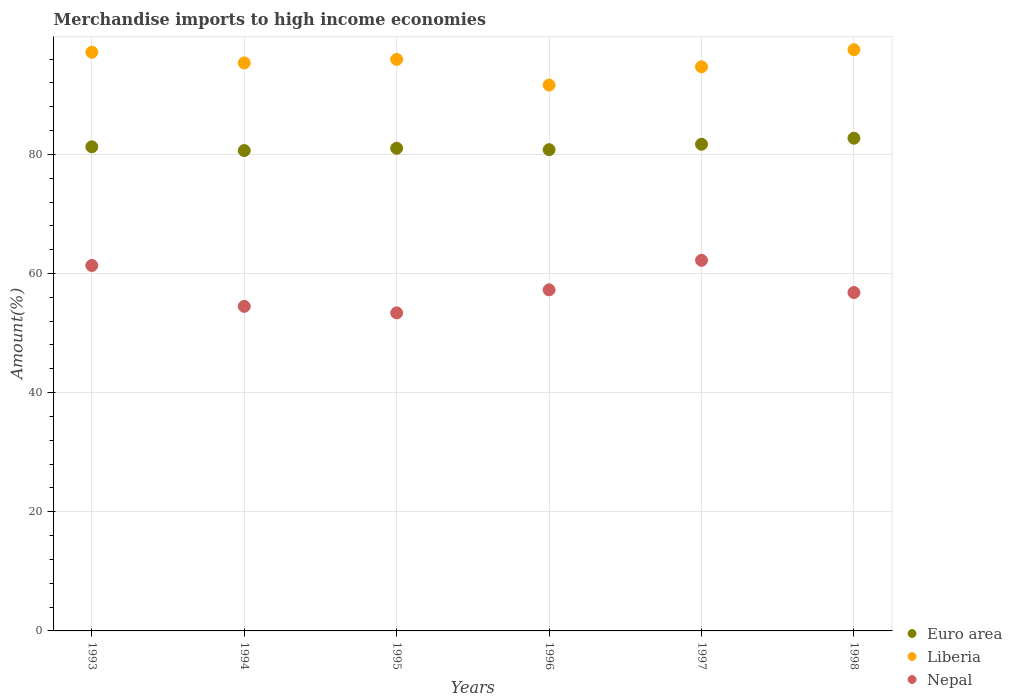How many different coloured dotlines are there?
Provide a succinct answer. 3. What is the percentage of amount earned from merchandise imports in Euro area in 1993?
Your response must be concise. 81.27. Across all years, what is the maximum percentage of amount earned from merchandise imports in Euro area?
Your answer should be compact. 82.71. Across all years, what is the minimum percentage of amount earned from merchandise imports in Euro area?
Offer a terse response. 80.64. In which year was the percentage of amount earned from merchandise imports in Nepal minimum?
Offer a very short reply. 1995. What is the total percentage of amount earned from merchandise imports in Nepal in the graph?
Offer a very short reply. 345.49. What is the difference between the percentage of amount earned from merchandise imports in Euro area in 1997 and that in 1998?
Ensure brevity in your answer.  -1.01. What is the difference between the percentage of amount earned from merchandise imports in Euro area in 1998 and the percentage of amount earned from merchandise imports in Liberia in 1995?
Keep it short and to the point. -13.23. What is the average percentage of amount earned from merchandise imports in Liberia per year?
Offer a terse response. 95.39. In the year 1998, what is the difference between the percentage of amount earned from merchandise imports in Nepal and percentage of amount earned from merchandise imports in Euro area?
Keep it short and to the point. -25.91. In how many years, is the percentage of amount earned from merchandise imports in Liberia greater than 84 %?
Ensure brevity in your answer.  6. What is the ratio of the percentage of amount earned from merchandise imports in Liberia in 1993 to that in 1996?
Make the answer very short. 1.06. Is the percentage of amount earned from merchandise imports in Nepal in 1993 less than that in 1996?
Offer a terse response. No. Is the difference between the percentage of amount earned from merchandise imports in Nepal in 1996 and 1997 greater than the difference between the percentage of amount earned from merchandise imports in Euro area in 1996 and 1997?
Make the answer very short. No. What is the difference between the highest and the second highest percentage of amount earned from merchandise imports in Nepal?
Make the answer very short. 0.86. What is the difference between the highest and the lowest percentage of amount earned from merchandise imports in Euro area?
Make the answer very short. 2.07. In how many years, is the percentage of amount earned from merchandise imports in Liberia greater than the average percentage of amount earned from merchandise imports in Liberia taken over all years?
Your answer should be very brief. 3. Is the sum of the percentage of amount earned from merchandise imports in Nepal in 1993 and 1997 greater than the maximum percentage of amount earned from merchandise imports in Euro area across all years?
Provide a succinct answer. Yes. Is it the case that in every year, the sum of the percentage of amount earned from merchandise imports in Euro area and percentage of amount earned from merchandise imports in Nepal  is greater than the percentage of amount earned from merchandise imports in Liberia?
Provide a succinct answer. Yes. How many dotlines are there?
Offer a terse response. 3. Does the graph contain grids?
Make the answer very short. Yes. Where does the legend appear in the graph?
Your response must be concise. Bottom right. What is the title of the graph?
Your response must be concise. Merchandise imports to high income economies. Does "Namibia" appear as one of the legend labels in the graph?
Your response must be concise. No. What is the label or title of the X-axis?
Make the answer very short. Years. What is the label or title of the Y-axis?
Your answer should be compact. Amount(%). What is the Amount(%) in Euro area in 1993?
Offer a terse response. 81.27. What is the Amount(%) of Liberia in 1993?
Your answer should be compact. 97.14. What is the Amount(%) in Nepal in 1993?
Offer a terse response. 61.35. What is the Amount(%) of Euro area in 1994?
Make the answer very short. 80.64. What is the Amount(%) of Liberia in 1994?
Make the answer very short. 95.35. What is the Amount(%) of Nepal in 1994?
Your answer should be very brief. 54.48. What is the Amount(%) of Euro area in 1995?
Provide a short and direct response. 81.02. What is the Amount(%) of Liberia in 1995?
Your answer should be very brief. 95.94. What is the Amount(%) in Nepal in 1995?
Keep it short and to the point. 53.39. What is the Amount(%) in Euro area in 1996?
Your response must be concise. 80.79. What is the Amount(%) in Liberia in 1996?
Give a very brief answer. 91.63. What is the Amount(%) in Nepal in 1996?
Ensure brevity in your answer.  57.26. What is the Amount(%) in Euro area in 1997?
Your answer should be compact. 81.7. What is the Amount(%) of Liberia in 1997?
Your response must be concise. 94.7. What is the Amount(%) of Nepal in 1997?
Offer a very short reply. 62.21. What is the Amount(%) in Euro area in 1998?
Provide a short and direct response. 82.71. What is the Amount(%) in Liberia in 1998?
Offer a very short reply. 97.56. What is the Amount(%) of Nepal in 1998?
Ensure brevity in your answer.  56.81. Across all years, what is the maximum Amount(%) of Euro area?
Your response must be concise. 82.71. Across all years, what is the maximum Amount(%) in Liberia?
Offer a very short reply. 97.56. Across all years, what is the maximum Amount(%) in Nepal?
Your response must be concise. 62.21. Across all years, what is the minimum Amount(%) in Euro area?
Give a very brief answer. 80.64. Across all years, what is the minimum Amount(%) in Liberia?
Ensure brevity in your answer.  91.63. Across all years, what is the minimum Amount(%) in Nepal?
Keep it short and to the point. 53.39. What is the total Amount(%) of Euro area in the graph?
Offer a terse response. 488.12. What is the total Amount(%) of Liberia in the graph?
Your response must be concise. 572.33. What is the total Amount(%) of Nepal in the graph?
Ensure brevity in your answer.  345.5. What is the difference between the Amount(%) of Euro area in 1993 and that in 1994?
Your answer should be compact. 0.63. What is the difference between the Amount(%) in Liberia in 1993 and that in 1994?
Your answer should be compact. 1.8. What is the difference between the Amount(%) in Nepal in 1993 and that in 1994?
Provide a succinct answer. 6.86. What is the difference between the Amount(%) of Euro area in 1993 and that in 1995?
Your response must be concise. 0.25. What is the difference between the Amount(%) of Liberia in 1993 and that in 1995?
Give a very brief answer. 1.21. What is the difference between the Amount(%) in Nepal in 1993 and that in 1995?
Offer a terse response. 7.95. What is the difference between the Amount(%) in Euro area in 1993 and that in 1996?
Ensure brevity in your answer.  0.49. What is the difference between the Amount(%) in Liberia in 1993 and that in 1996?
Keep it short and to the point. 5.51. What is the difference between the Amount(%) of Nepal in 1993 and that in 1996?
Provide a succinct answer. 4.09. What is the difference between the Amount(%) in Euro area in 1993 and that in 1997?
Provide a short and direct response. -0.43. What is the difference between the Amount(%) in Liberia in 1993 and that in 1997?
Give a very brief answer. 2.44. What is the difference between the Amount(%) of Nepal in 1993 and that in 1997?
Give a very brief answer. -0.86. What is the difference between the Amount(%) of Euro area in 1993 and that in 1998?
Your answer should be very brief. -1.44. What is the difference between the Amount(%) in Liberia in 1993 and that in 1998?
Your answer should be very brief. -0.42. What is the difference between the Amount(%) of Nepal in 1993 and that in 1998?
Your response must be concise. 4.54. What is the difference between the Amount(%) of Euro area in 1994 and that in 1995?
Give a very brief answer. -0.38. What is the difference between the Amount(%) in Liberia in 1994 and that in 1995?
Offer a terse response. -0.59. What is the difference between the Amount(%) of Nepal in 1994 and that in 1995?
Your response must be concise. 1.09. What is the difference between the Amount(%) in Euro area in 1994 and that in 1996?
Give a very brief answer. -0.15. What is the difference between the Amount(%) in Liberia in 1994 and that in 1996?
Your answer should be compact. 3.72. What is the difference between the Amount(%) of Nepal in 1994 and that in 1996?
Your answer should be compact. -2.77. What is the difference between the Amount(%) in Euro area in 1994 and that in 1997?
Offer a very short reply. -1.06. What is the difference between the Amount(%) in Liberia in 1994 and that in 1997?
Offer a very short reply. 0.65. What is the difference between the Amount(%) of Nepal in 1994 and that in 1997?
Provide a succinct answer. -7.73. What is the difference between the Amount(%) of Euro area in 1994 and that in 1998?
Offer a terse response. -2.07. What is the difference between the Amount(%) in Liberia in 1994 and that in 1998?
Ensure brevity in your answer.  -2.22. What is the difference between the Amount(%) in Nepal in 1994 and that in 1998?
Give a very brief answer. -2.32. What is the difference between the Amount(%) in Euro area in 1995 and that in 1996?
Your answer should be compact. 0.24. What is the difference between the Amount(%) of Liberia in 1995 and that in 1996?
Keep it short and to the point. 4.31. What is the difference between the Amount(%) of Nepal in 1995 and that in 1996?
Keep it short and to the point. -3.87. What is the difference between the Amount(%) of Euro area in 1995 and that in 1997?
Offer a terse response. -0.68. What is the difference between the Amount(%) in Liberia in 1995 and that in 1997?
Provide a short and direct response. 1.24. What is the difference between the Amount(%) of Nepal in 1995 and that in 1997?
Provide a short and direct response. -8.82. What is the difference between the Amount(%) in Euro area in 1995 and that in 1998?
Ensure brevity in your answer.  -1.69. What is the difference between the Amount(%) of Liberia in 1995 and that in 1998?
Your answer should be very brief. -1.63. What is the difference between the Amount(%) in Nepal in 1995 and that in 1998?
Your response must be concise. -3.41. What is the difference between the Amount(%) in Euro area in 1996 and that in 1997?
Make the answer very short. -0.91. What is the difference between the Amount(%) in Liberia in 1996 and that in 1997?
Ensure brevity in your answer.  -3.07. What is the difference between the Amount(%) in Nepal in 1996 and that in 1997?
Give a very brief answer. -4.95. What is the difference between the Amount(%) of Euro area in 1996 and that in 1998?
Keep it short and to the point. -1.93. What is the difference between the Amount(%) of Liberia in 1996 and that in 1998?
Ensure brevity in your answer.  -5.93. What is the difference between the Amount(%) of Nepal in 1996 and that in 1998?
Your answer should be compact. 0.45. What is the difference between the Amount(%) of Euro area in 1997 and that in 1998?
Keep it short and to the point. -1.01. What is the difference between the Amount(%) of Liberia in 1997 and that in 1998?
Give a very brief answer. -2.86. What is the difference between the Amount(%) in Nepal in 1997 and that in 1998?
Your answer should be very brief. 5.41. What is the difference between the Amount(%) of Euro area in 1993 and the Amount(%) of Liberia in 1994?
Your answer should be compact. -14.08. What is the difference between the Amount(%) of Euro area in 1993 and the Amount(%) of Nepal in 1994?
Offer a very short reply. 26.79. What is the difference between the Amount(%) of Liberia in 1993 and the Amount(%) of Nepal in 1994?
Keep it short and to the point. 42.66. What is the difference between the Amount(%) in Euro area in 1993 and the Amount(%) in Liberia in 1995?
Provide a short and direct response. -14.67. What is the difference between the Amount(%) in Euro area in 1993 and the Amount(%) in Nepal in 1995?
Provide a short and direct response. 27.88. What is the difference between the Amount(%) of Liberia in 1993 and the Amount(%) of Nepal in 1995?
Ensure brevity in your answer.  43.75. What is the difference between the Amount(%) of Euro area in 1993 and the Amount(%) of Liberia in 1996?
Your response must be concise. -10.36. What is the difference between the Amount(%) of Euro area in 1993 and the Amount(%) of Nepal in 1996?
Provide a short and direct response. 24.01. What is the difference between the Amount(%) in Liberia in 1993 and the Amount(%) in Nepal in 1996?
Your response must be concise. 39.89. What is the difference between the Amount(%) of Euro area in 1993 and the Amount(%) of Liberia in 1997?
Offer a very short reply. -13.43. What is the difference between the Amount(%) in Euro area in 1993 and the Amount(%) in Nepal in 1997?
Offer a terse response. 19.06. What is the difference between the Amount(%) in Liberia in 1993 and the Amount(%) in Nepal in 1997?
Give a very brief answer. 34.93. What is the difference between the Amount(%) in Euro area in 1993 and the Amount(%) in Liberia in 1998?
Provide a short and direct response. -16.29. What is the difference between the Amount(%) of Euro area in 1993 and the Amount(%) of Nepal in 1998?
Offer a very short reply. 24.47. What is the difference between the Amount(%) in Liberia in 1993 and the Amount(%) in Nepal in 1998?
Make the answer very short. 40.34. What is the difference between the Amount(%) in Euro area in 1994 and the Amount(%) in Liberia in 1995?
Make the answer very short. -15.3. What is the difference between the Amount(%) in Euro area in 1994 and the Amount(%) in Nepal in 1995?
Give a very brief answer. 27.25. What is the difference between the Amount(%) of Liberia in 1994 and the Amount(%) of Nepal in 1995?
Offer a very short reply. 41.96. What is the difference between the Amount(%) of Euro area in 1994 and the Amount(%) of Liberia in 1996?
Keep it short and to the point. -10.99. What is the difference between the Amount(%) of Euro area in 1994 and the Amount(%) of Nepal in 1996?
Your response must be concise. 23.38. What is the difference between the Amount(%) of Liberia in 1994 and the Amount(%) of Nepal in 1996?
Offer a very short reply. 38.09. What is the difference between the Amount(%) of Euro area in 1994 and the Amount(%) of Liberia in 1997?
Provide a short and direct response. -14.06. What is the difference between the Amount(%) in Euro area in 1994 and the Amount(%) in Nepal in 1997?
Offer a very short reply. 18.43. What is the difference between the Amount(%) of Liberia in 1994 and the Amount(%) of Nepal in 1997?
Your answer should be very brief. 33.14. What is the difference between the Amount(%) in Euro area in 1994 and the Amount(%) in Liberia in 1998?
Offer a very short reply. -16.93. What is the difference between the Amount(%) in Euro area in 1994 and the Amount(%) in Nepal in 1998?
Your response must be concise. 23.83. What is the difference between the Amount(%) in Liberia in 1994 and the Amount(%) in Nepal in 1998?
Keep it short and to the point. 38.54. What is the difference between the Amount(%) of Euro area in 1995 and the Amount(%) of Liberia in 1996?
Give a very brief answer. -10.61. What is the difference between the Amount(%) of Euro area in 1995 and the Amount(%) of Nepal in 1996?
Make the answer very short. 23.76. What is the difference between the Amount(%) of Liberia in 1995 and the Amount(%) of Nepal in 1996?
Your answer should be compact. 38.68. What is the difference between the Amount(%) of Euro area in 1995 and the Amount(%) of Liberia in 1997?
Provide a succinct answer. -13.68. What is the difference between the Amount(%) of Euro area in 1995 and the Amount(%) of Nepal in 1997?
Your response must be concise. 18.81. What is the difference between the Amount(%) in Liberia in 1995 and the Amount(%) in Nepal in 1997?
Ensure brevity in your answer.  33.73. What is the difference between the Amount(%) in Euro area in 1995 and the Amount(%) in Liberia in 1998?
Keep it short and to the point. -16.54. What is the difference between the Amount(%) of Euro area in 1995 and the Amount(%) of Nepal in 1998?
Ensure brevity in your answer.  24.22. What is the difference between the Amount(%) of Liberia in 1995 and the Amount(%) of Nepal in 1998?
Offer a terse response. 39.13. What is the difference between the Amount(%) of Euro area in 1996 and the Amount(%) of Liberia in 1997?
Keep it short and to the point. -13.91. What is the difference between the Amount(%) of Euro area in 1996 and the Amount(%) of Nepal in 1997?
Provide a short and direct response. 18.57. What is the difference between the Amount(%) of Liberia in 1996 and the Amount(%) of Nepal in 1997?
Provide a short and direct response. 29.42. What is the difference between the Amount(%) of Euro area in 1996 and the Amount(%) of Liberia in 1998?
Make the answer very short. -16.78. What is the difference between the Amount(%) of Euro area in 1996 and the Amount(%) of Nepal in 1998?
Offer a very short reply. 23.98. What is the difference between the Amount(%) in Liberia in 1996 and the Amount(%) in Nepal in 1998?
Provide a short and direct response. 34.83. What is the difference between the Amount(%) of Euro area in 1997 and the Amount(%) of Liberia in 1998?
Ensure brevity in your answer.  -15.87. What is the difference between the Amount(%) in Euro area in 1997 and the Amount(%) in Nepal in 1998?
Your answer should be very brief. 24.89. What is the difference between the Amount(%) in Liberia in 1997 and the Amount(%) in Nepal in 1998?
Offer a very short reply. 37.89. What is the average Amount(%) in Euro area per year?
Make the answer very short. 81.35. What is the average Amount(%) of Liberia per year?
Make the answer very short. 95.39. What is the average Amount(%) in Nepal per year?
Your response must be concise. 57.58. In the year 1993, what is the difference between the Amount(%) of Euro area and Amount(%) of Liberia?
Give a very brief answer. -15.87. In the year 1993, what is the difference between the Amount(%) of Euro area and Amount(%) of Nepal?
Ensure brevity in your answer.  19.93. In the year 1993, what is the difference between the Amount(%) of Liberia and Amount(%) of Nepal?
Provide a short and direct response. 35.8. In the year 1994, what is the difference between the Amount(%) in Euro area and Amount(%) in Liberia?
Offer a very short reply. -14.71. In the year 1994, what is the difference between the Amount(%) of Euro area and Amount(%) of Nepal?
Offer a very short reply. 26.15. In the year 1994, what is the difference between the Amount(%) of Liberia and Amount(%) of Nepal?
Your answer should be very brief. 40.86. In the year 1995, what is the difference between the Amount(%) in Euro area and Amount(%) in Liberia?
Give a very brief answer. -14.92. In the year 1995, what is the difference between the Amount(%) of Euro area and Amount(%) of Nepal?
Offer a terse response. 27.63. In the year 1995, what is the difference between the Amount(%) of Liberia and Amount(%) of Nepal?
Your answer should be very brief. 42.55. In the year 1996, what is the difference between the Amount(%) of Euro area and Amount(%) of Liberia?
Your response must be concise. -10.85. In the year 1996, what is the difference between the Amount(%) of Euro area and Amount(%) of Nepal?
Offer a terse response. 23.53. In the year 1996, what is the difference between the Amount(%) of Liberia and Amount(%) of Nepal?
Offer a very short reply. 34.38. In the year 1997, what is the difference between the Amount(%) of Euro area and Amount(%) of Liberia?
Ensure brevity in your answer.  -13. In the year 1997, what is the difference between the Amount(%) in Euro area and Amount(%) in Nepal?
Keep it short and to the point. 19.49. In the year 1997, what is the difference between the Amount(%) in Liberia and Amount(%) in Nepal?
Offer a very short reply. 32.49. In the year 1998, what is the difference between the Amount(%) of Euro area and Amount(%) of Liberia?
Your answer should be very brief. -14.85. In the year 1998, what is the difference between the Amount(%) in Euro area and Amount(%) in Nepal?
Your answer should be very brief. 25.91. In the year 1998, what is the difference between the Amount(%) of Liberia and Amount(%) of Nepal?
Make the answer very short. 40.76. What is the ratio of the Amount(%) of Euro area in 1993 to that in 1994?
Make the answer very short. 1.01. What is the ratio of the Amount(%) in Liberia in 1993 to that in 1994?
Provide a succinct answer. 1.02. What is the ratio of the Amount(%) of Nepal in 1993 to that in 1994?
Offer a terse response. 1.13. What is the ratio of the Amount(%) in Euro area in 1993 to that in 1995?
Make the answer very short. 1. What is the ratio of the Amount(%) of Liberia in 1993 to that in 1995?
Your response must be concise. 1.01. What is the ratio of the Amount(%) in Nepal in 1993 to that in 1995?
Give a very brief answer. 1.15. What is the ratio of the Amount(%) of Euro area in 1993 to that in 1996?
Ensure brevity in your answer.  1.01. What is the ratio of the Amount(%) of Liberia in 1993 to that in 1996?
Your answer should be compact. 1.06. What is the ratio of the Amount(%) in Nepal in 1993 to that in 1996?
Your answer should be compact. 1.07. What is the ratio of the Amount(%) of Liberia in 1993 to that in 1997?
Give a very brief answer. 1.03. What is the ratio of the Amount(%) in Nepal in 1993 to that in 1997?
Provide a short and direct response. 0.99. What is the ratio of the Amount(%) of Euro area in 1993 to that in 1998?
Provide a short and direct response. 0.98. What is the ratio of the Amount(%) in Nepal in 1993 to that in 1998?
Provide a succinct answer. 1.08. What is the ratio of the Amount(%) of Euro area in 1994 to that in 1995?
Ensure brevity in your answer.  1. What is the ratio of the Amount(%) in Liberia in 1994 to that in 1995?
Provide a short and direct response. 0.99. What is the ratio of the Amount(%) in Nepal in 1994 to that in 1995?
Provide a short and direct response. 1.02. What is the ratio of the Amount(%) of Euro area in 1994 to that in 1996?
Provide a succinct answer. 1. What is the ratio of the Amount(%) in Liberia in 1994 to that in 1996?
Your answer should be very brief. 1.04. What is the ratio of the Amount(%) in Nepal in 1994 to that in 1996?
Offer a very short reply. 0.95. What is the ratio of the Amount(%) in Euro area in 1994 to that in 1997?
Ensure brevity in your answer.  0.99. What is the ratio of the Amount(%) of Liberia in 1994 to that in 1997?
Your answer should be very brief. 1.01. What is the ratio of the Amount(%) of Nepal in 1994 to that in 1997?
Provide a succinct answer. 0.88. What is the ratio of the Amount(%) in Euro area in 1994 to that in 1998?
Offer a terse response. 0.97. What is the ratio of the Amount(%) in Liberia in 1994 to that in 1998?
Ensure brevity in your answer.  0.98. What is the ratio of the Amount(%) of Nepal in 1994 to that in 1998?
Give a very brief answer. 0.96. What is the ratio of the Amount(%) in Liberia in 1995 to that in 1996?
Provide a succinct answer. 1.05. What is the ratio of the Amount(%) of Nepal in 1995 to that in 1996?
Your response must be concise. 0.93. What is the ratio of the Amount(%) in Liberia in 1995 to that in 1997?
Offer a very short reply. 1.01. What is the ratio of the Amount(%) of Nepal in 1995 to that in 1997?
Your response must be concise. 0.86. What is the ratio of the Amount(%) in Euro area in 1995 to that in 1998?
Give a very brief answer. 0.98. What is the ratio of the Amount(%) in Liberia in 1995 to that in 1998?
Your answer should be very brief. 0.98. What is the ratio of the Amount(%) of Nepal in 1995 to that in 1998?
Provide a succinct answer. 0.94. What is the ratio of the Amount(%) of Euro area in 1996 to that in 1997?
Give a very brief answer. 0.99. What is the ratio of the Amount(%) of Liberia in 1996 to that in 1997?
Your answer should be very brief. 0.97. What is the ratio of the Amount(%) of Nepal in 1996 to that in 1997?
Ensure brevity in your answer.  0.92. What is the ratio of the Amount(%) in Euro area in 1996 to that in 1998?
Offer a terse response. 0.98. What is the ratio of the Amount(%) in Liberia in 1996 to that in 1998?
Your answer should be very brief. 0.94. What is the ratio of the Amount(%) of Euro area in 1997 to that in 1998?
Make the answer very short. 0.99. What is the ratio of the Amount(%) in Liberia in 1997 to that in 1998?
Provide a short and direct response. 0.97. What is the ratio of the Amount(%) in Nepal in 1997 to that in 1998?
Provide a short and direct response. 1.1. What is the difference between the highest and the second highest Amount(%) in Liberia?
Provide a succinct answer. 0.42. What is the difference between the highest and the second highest Amount(%) in Nepal?
Keep it short and to the point. 0.86. What is the difference between the highest and the lowest Amount(%) in Euro area?
Keep it short and to the point. 2.07. What is the difference between the highest and the lowest Amount(%) of Liberia?
Provide a short and direct response. 5.93. What is the difference between the highest and the lowest Amount(%) of Nepal?
Keep it short and to the point. 8.82. 